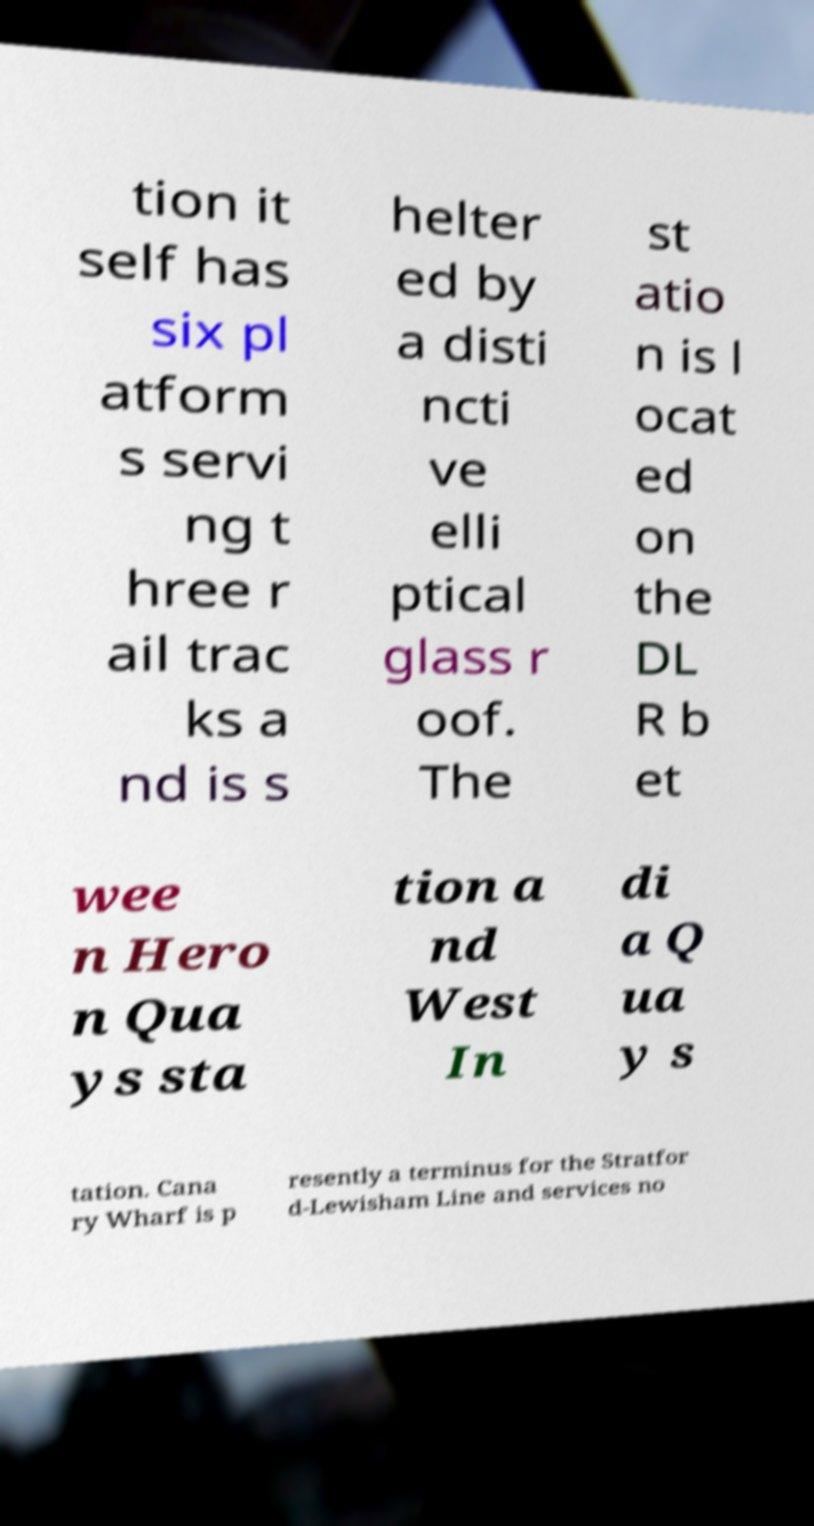Please identify and transcribe the text found in this image. tion it self has six pl atform s servi ng t hree r ail trac ks a nd is s helter ed by a disti ncti ve elli ptical glass r oof. The st atio n is l ocat ed on the DL R b et wee n Hero n Qua ys sta tion a nd West In di a Q ua y s tation. Cana ry Wharf is p resently a terminus for the Stratfor d-Lewisham Line and services no 